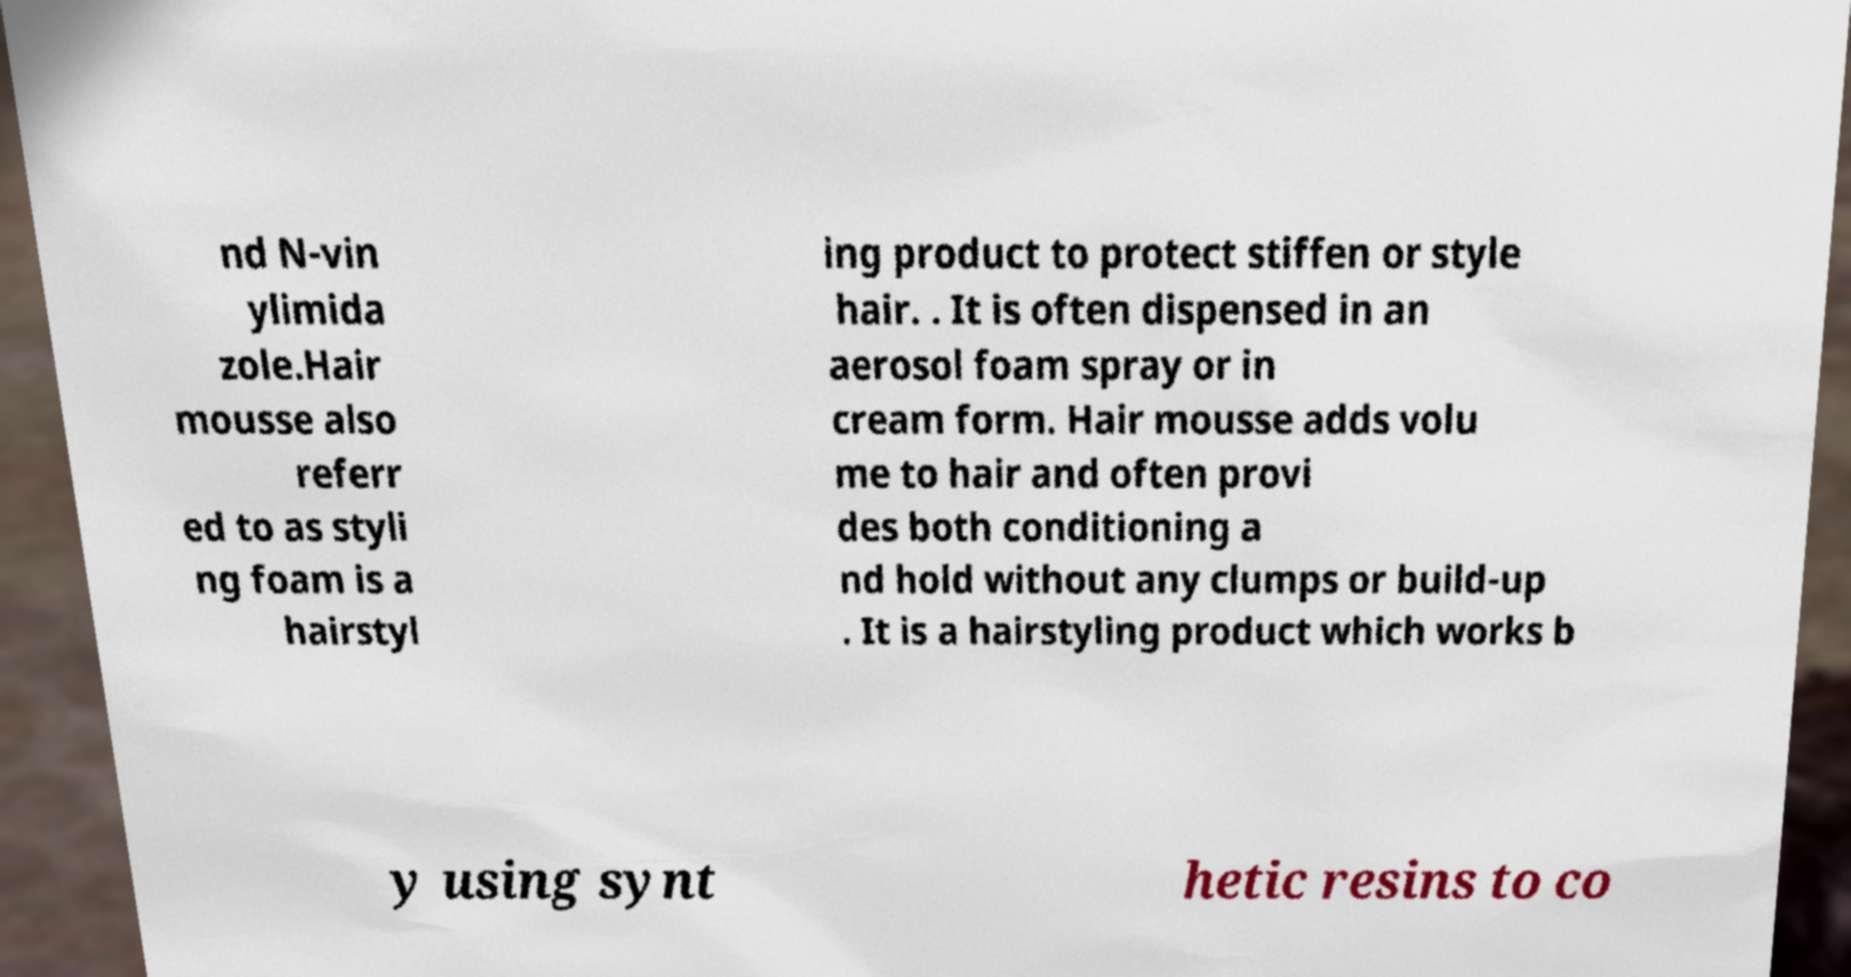Could you extract and type out the text from this image? nd N-vin ylimida zole.Hair mousse also referr ed to as styli ng foam is a hairstyl ing product to protect stiffen or style hair. . It is often dispensed in an aerosol foam spray or in cream form. Hair mousse adds volu me to hair and often provi des both conditioning a nd hold without any clumps or build-up . It is a hairstyling product which works b y using synt hetic resins to co 